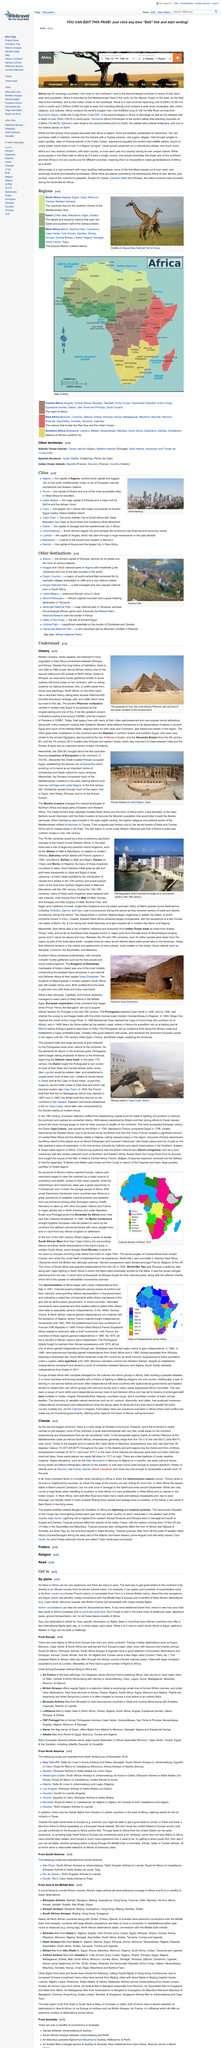Indicate a few pertinent items in this graphic. Traveling to Malawi or Togo can be a significant challenge due to their remote locations. Traveling by plane is a viable option for reaching Africa. The climate in this region is the primary focus of this article, which discusses its impact on the local flora and fauna. The article "Climate" categorizes the regions of Northern Morocco and the Mediterranean coast of South Africa as temperate regions. These areas have a moderate climate with mild winters and warm summers. Yes, there are ways to save on airfares to Africa. 